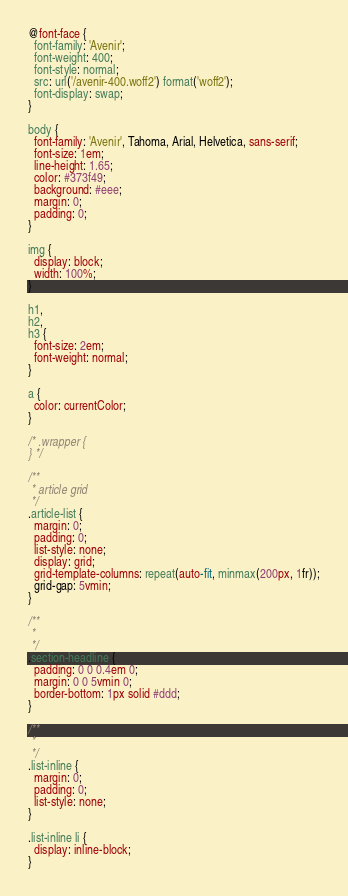Convert code to text. <code><loc_0><loc_0><loc_500><loc_500><_CSS_>@font-face {
  font-family: 'Avenir';
  font-weight: 400;
  font-style: normal;
  src: url('/avenir-400.woff2') format('woff2');
  font-display: swap;
}

body {
  font-family: 'Avenir', Tahoma, Arial, Helvetica, sans-serif;
  font-size: 1em;
  line-height: 1.65;
  color: #373f49;
  background: #eee;
  margin: 0;
  padding: 0;
}

img {
  display: block;
  width: 100%;
}

h1,
h2,
h3 {
  font-size: 2em;
  font-weight: normal;
}

a {
  color: currentColor;
}

/* .wrapper {
} */

/**
 * article grid
 */
.article-list {
  margin: 0;
  padding: 0;
  list-style: none;
  display: grid;
  grid-template-columns: repeat(auto-fit, minmax(200px, 1fr));
  grid-gap: 5vmin;
}

/**
 *
 */
.section-headline {
  padding: 0 0 0.4em 0;
  margin: 0 0 5vmin 0;
  border-bottom: 1px solid #ddd;
}

/**
 *
 */
.list-inline {
  margin: 0;
  padding: 0;
  list-style: none;
}

.list-inline li {
  display: inline-block;
}
</code> 